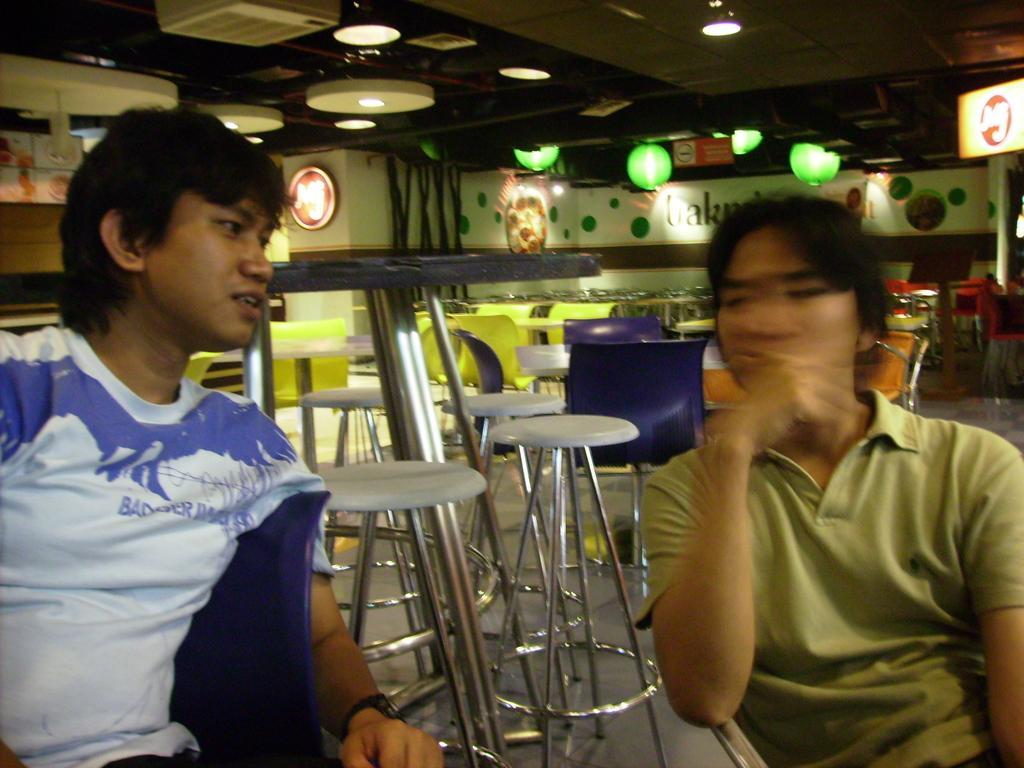How would you summarize this image in a sentence or two? In this Image I see 2 persons who are sitting on chairs and In the background I see lot of tables, chairs, stools and lights on the ceiling. 